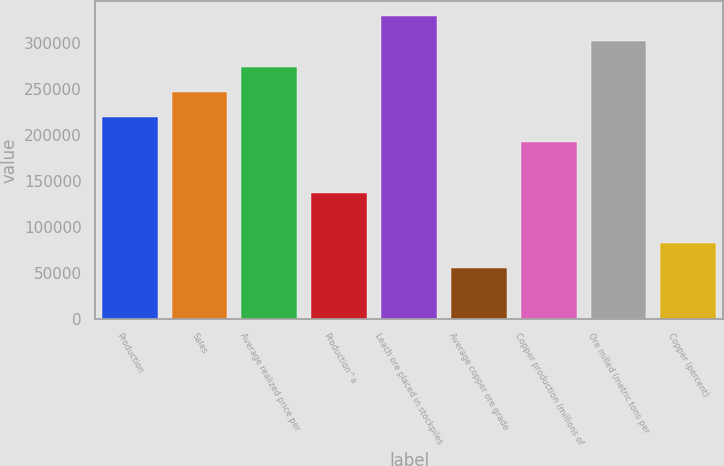Convert chart to OTSL. <chart><loc_0><loc_0><loc_500><loc_500><bar_chart><fcel>Production<fcel>Sales<fcel>Average realized price per<fcel>Production^a<fcel>Leach ore placed in stockpiles<fcel>Average copper ore grade<fcel>Copper production (millions of<fcel>Ore milled (metric tons per<fcel>Copper (percent)<nl><fcel>219680<fcel>247140<fcel>274600<fcel>137300<fcel>329520<fcel>54920<fcel>192220<fcel>302060<fcel>82380<nl></chart> 